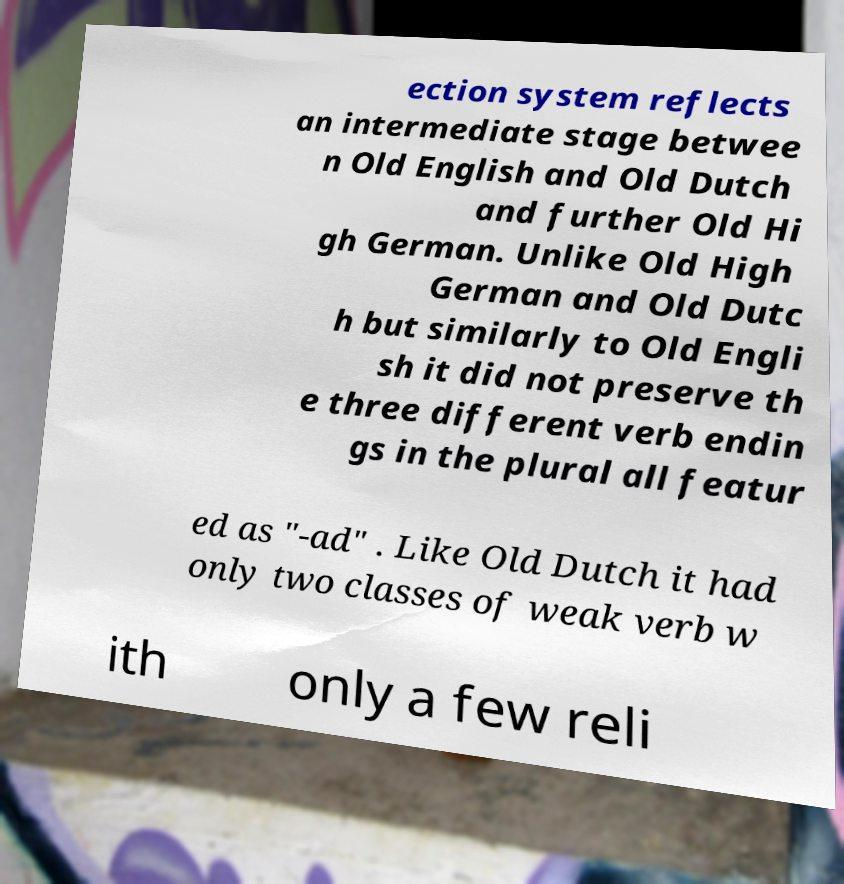Please read and relay the text visible in this image. What does it say? ection system reflects an intermediate stage betwee n Old English and Old Dutch and further Old Hi gh German. Unlike Old High German and Old Dutc h but similarly to Old Engli sh it did not preserve th e three different verb endin gs in the plural all featur ed as "-ad" . Like Old Dutch it had only two classes of weak verb w ith only a few reli 